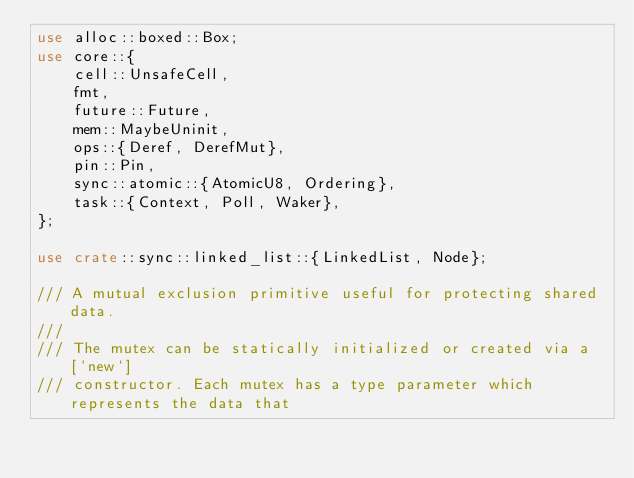<code> <loc_0><loc_0><loc_500><loc_500><_Rust_>use alloc::boxed::Box;
use core::{
    cell::UnsafeCell,
    fmt,
    future::Future,
    mem::MaybeUninit,
    ops::{Deref, DerefMut},
    pin::Pin,
    sync::atomic::{AtomicU8, Ordering},
    task::{Context, Poll, Waker},
};

use crate::sync::linked_list::{LinkedList, Node};

/// A mutual exclusion primitive useful for protecting shared data.
///
/// The mutex can be statically initialized or created via a [`new`]
/// constructor. Each mutex has a type parameter which represents the data that</code> 